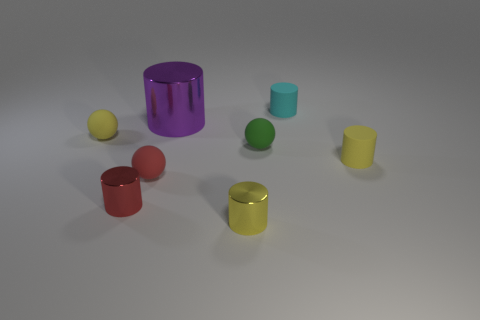Are there any patterns or symmetries in how the objects are placed? From this perspective, there are no clear patterns or symmetries. The objects are placed in a seemingly arbitrary fashion. Could the color arrangement signify anything? While the arrangement does not follow a conventional pattern, in a more abstract sense, the diverse colors could evoke a sense of variety or creativity. It might also simply be a random distribution without intended significance. 